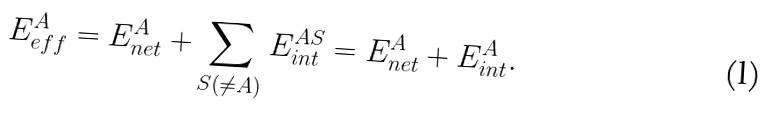<formula> <loc_0><loc_0><loc_500><loc_500>E _ { e f f } ^ { A } = E _ { n e t } ^ { A } + \sum _ { S ( \not = A ) } E _ { i n t } ^ { A S } = E _ { n e t } ^ { A } + E _ { i n t } ^ { A } .</formula> 